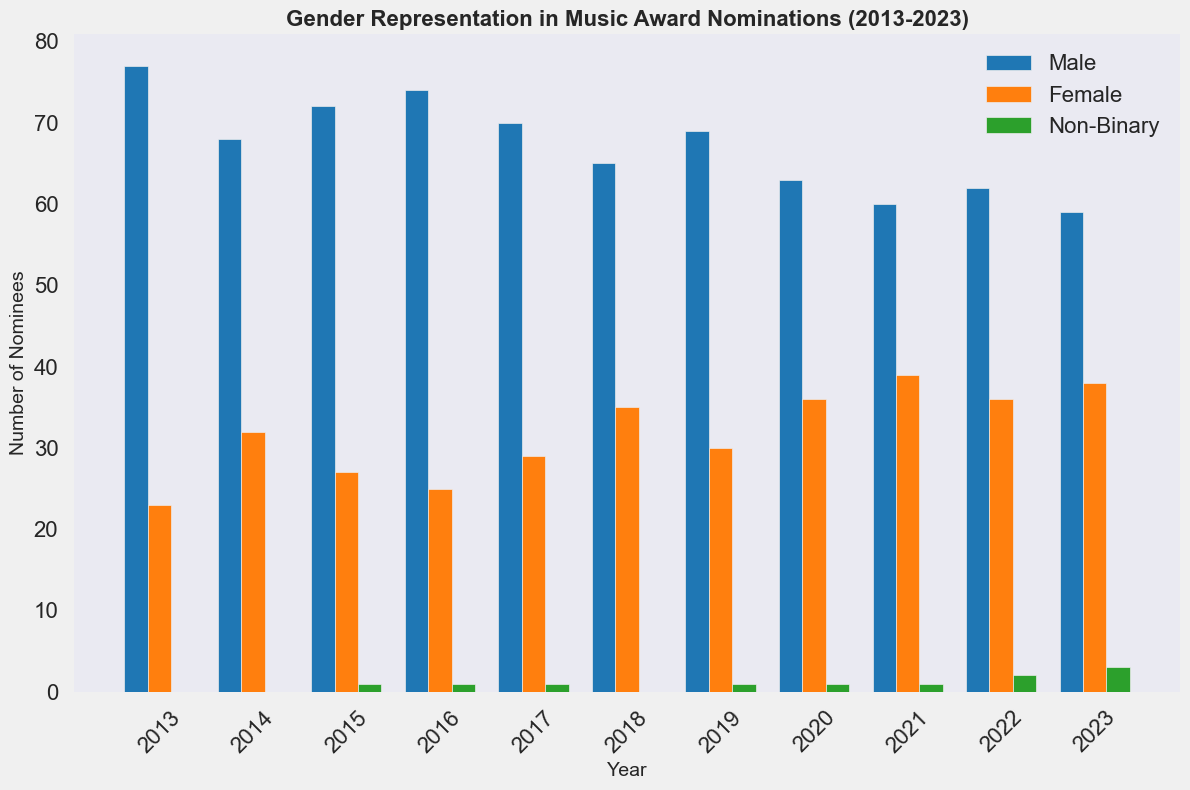Which year had the highest number of female nominees? By observing the height of the orange bars, we can see that 2021 had the highest number of female nominees.
Answer: 2021 What is the total number of nominees in 2023 across all gender categories? Summing the values of male, female, and non-binary nominees in 2023: 59 (Male) + 38 (Female) + 3 (Non-Binary) = 100.
Answer: 100 Over the decade, which gender category had the most consistent number of nominees each year? By comparing the bars over the years, male nominees (blue bars) seem to show the least fluctuation compared to female (orange) and non-binary (green) nominees.
Answer: Male How many more female nominees were there in 2018 compared to 2013? In 2018, there were 35 female nominees, while in 2013, there were 23. The difference is 35 - 23 = 12.
Answer: 12 Which year saw the first appearance of non-binary nominees? By observing the green bars, non-binary nominees first appeared in 2015.
Answer: 2015 What is the average number of male nominees from 2013 to 2023? Sum up the number of male nominees across the years: 77, 68, 72, 74, 70, 65, 69, 63, 60, 62, 59. The total is 739. Divide by 11 years: 739 / 11 = 67.18 (approximately).
Answer: 67.18 In which year did the nominees for non-binary surpass two? In 2023, the number of non-binary nominees surpassed two, reaching 3.
Answer: 2023 What trend can be observed in the number of female nominees over the past decade? The trend line of the orange bars generally shows an increasing pattern from 2013 to 2023.
Answer: Increasing trend Which year had the smallest gap between male and female nominees? In 2023, there were 59 male nominees and 38 female nominees, a gap of 21. Checking previous years' gaps, no smaller gap observed.
Answer: 2023 How does the number of male and female nominees in 2020 compare to their numbers in 2021? In 2020, there were 63 male and 36 female nominees. In 2021, there were 60 male and 39 female nominees. Hence a decrease of 3 for males and an increase of 3 for females.
Answer: Male decreased by 3, Female increased by 3 